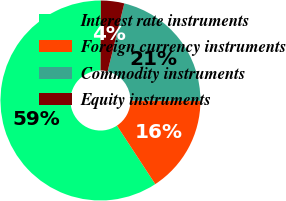Convert chart to OTSL. <chart><loc_0><loc_0><loc_500><loc_500><pie_chart><fcel>Interest rate instruments<fcel>Foreign currency instruments<fcel>Commodity instruments<fcel>Equity instruments<nl><fcel>59.3%<fcel>15.69%<fcel>21.24%<fcel>3.77%<nl></chart> 